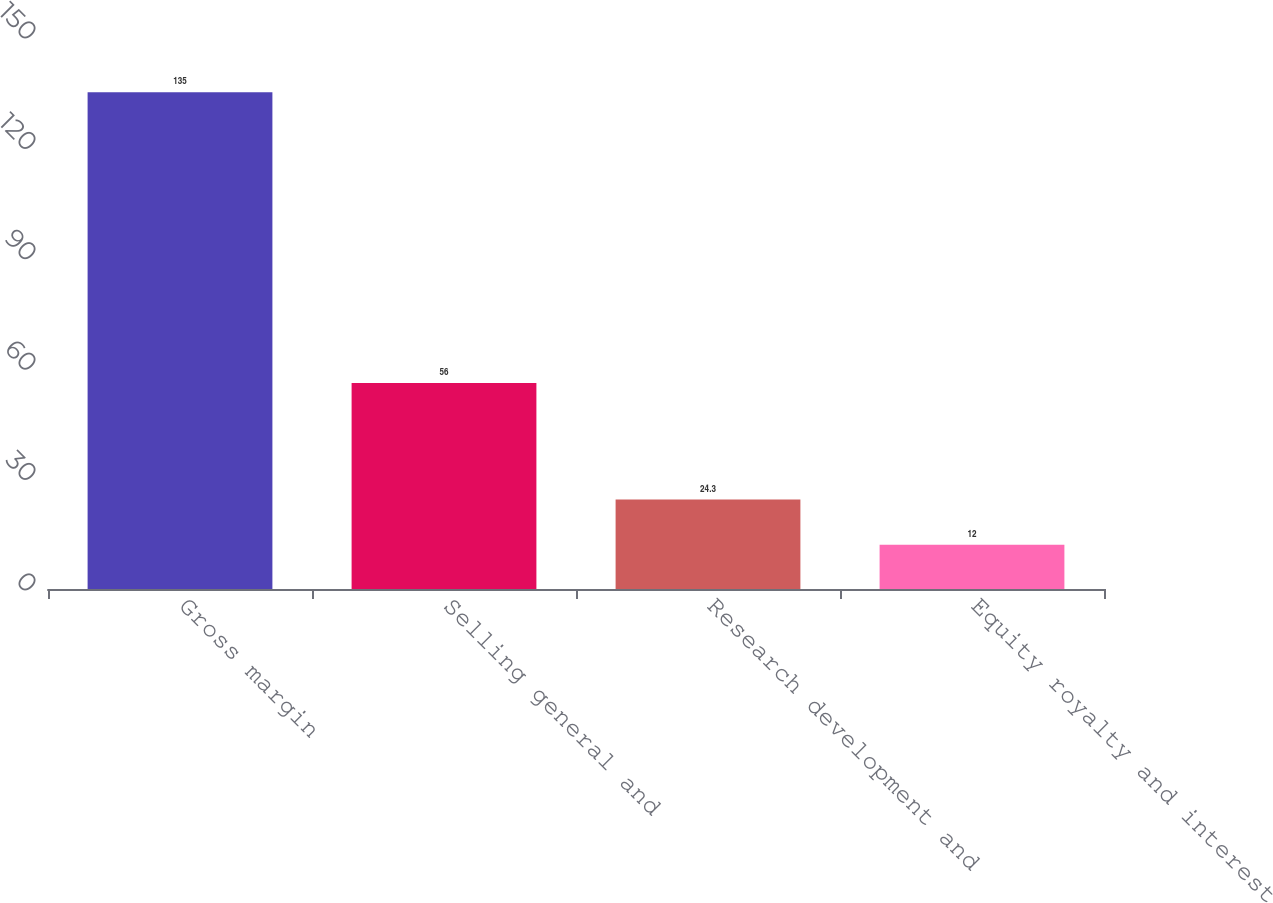Convert chart. <chart><loc_0><loc_0><loc_500><loc_500><bar_chart><fcel>Gross margin<fcel>Selling general and<fcel>Research development and<fcel>Equity royalty and interest<nl><fcel>135<fcel>56<fcel>24.3<fcel>12<nl></chart> 